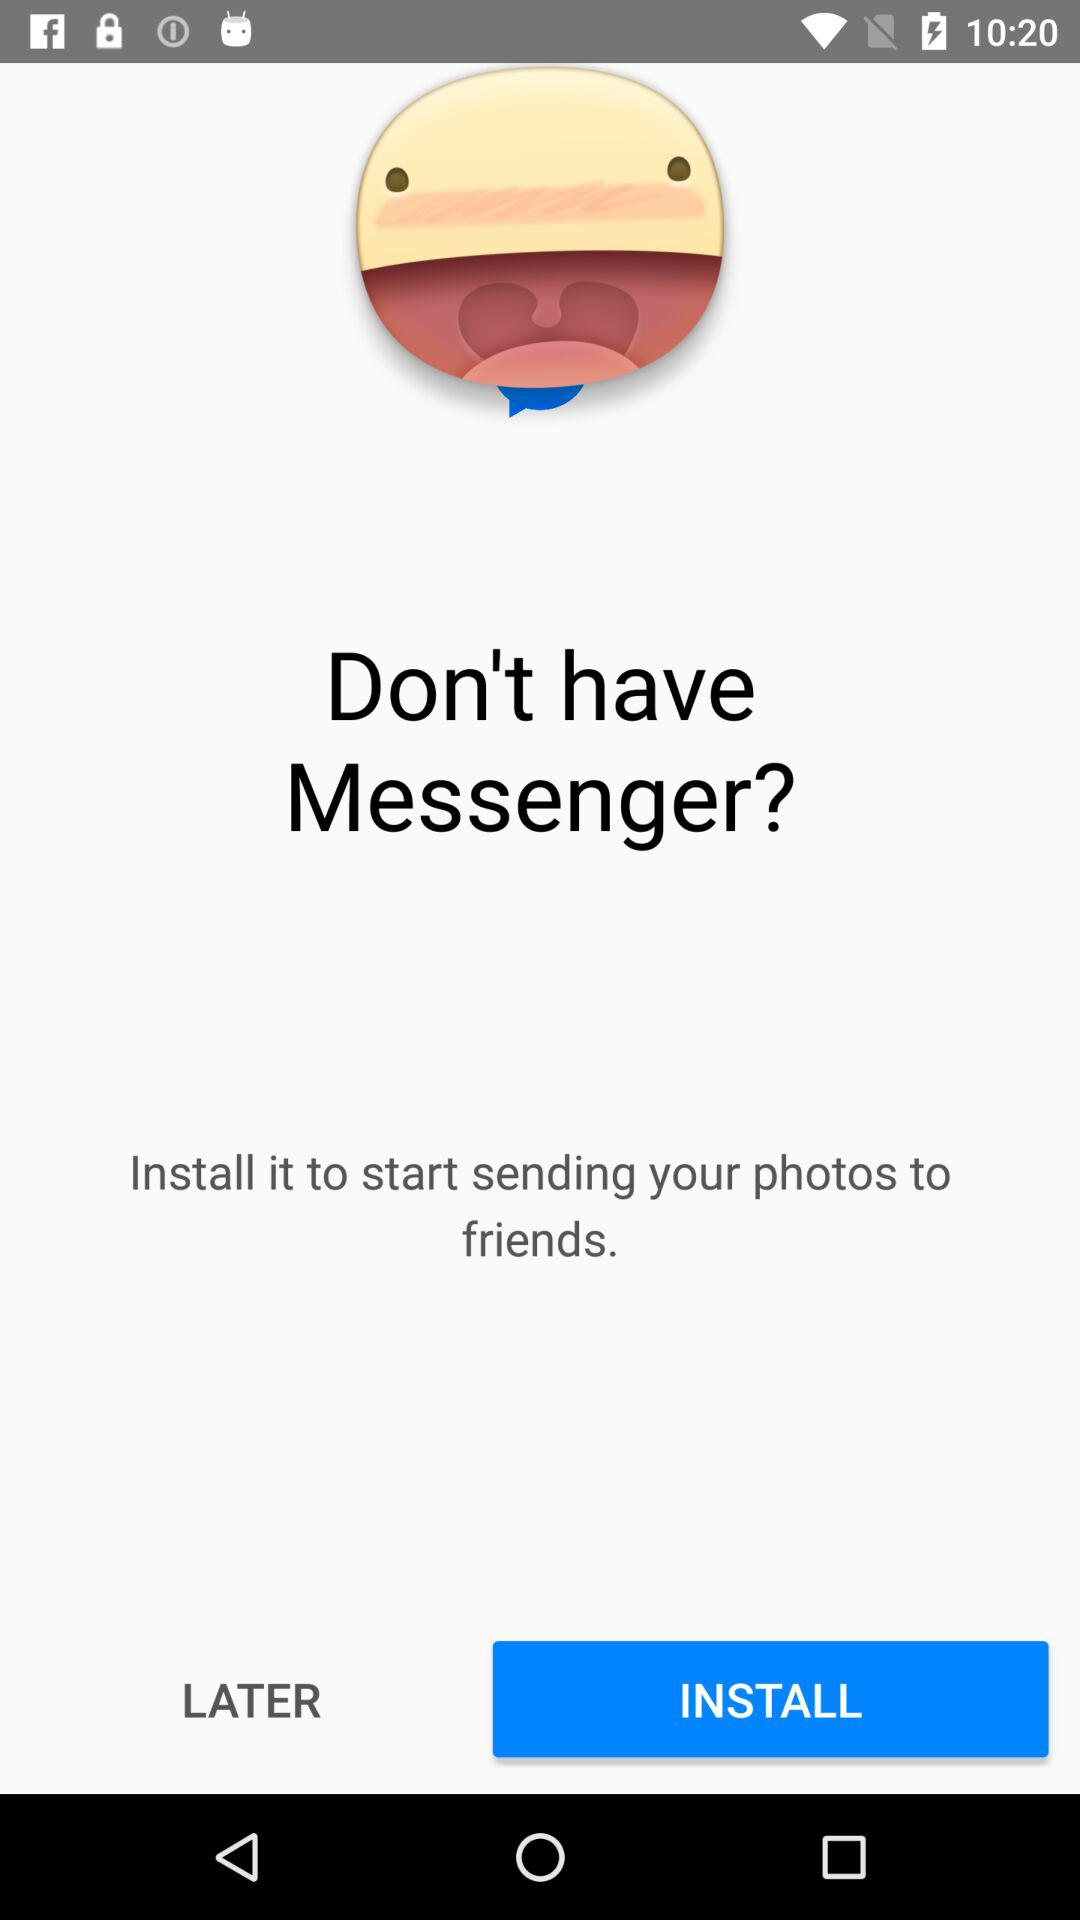What do we need to install to start sending our photos to friends? You need to install "Messenger" to start sending your photos to friends. 